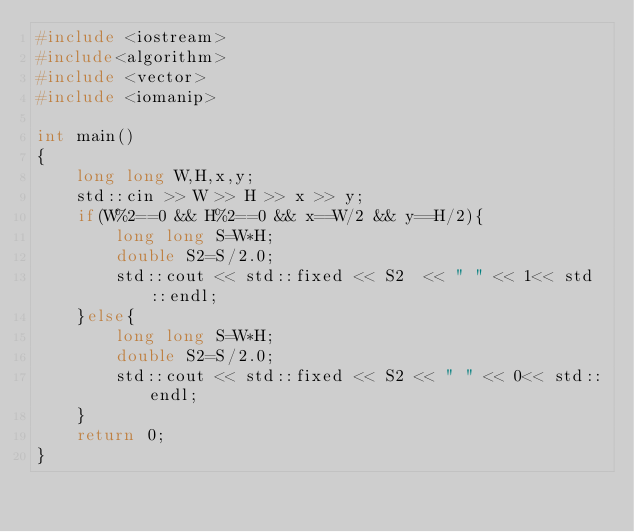<code> <loc_0><loc_0><loc_500><loc_500><_C++_>#include <iostream>
#include<algorithm>
#include <vector>
#include <iomanip>

int main()
{
    long long W,H,x,y;
    std::cin >> W >> H >> x >> y;
    if(W%2==0 && H%2==0 && x==W/2 && y==H/2){
        long long S=W*H;
        double S2=S/2.0;
        std::cout << std::fixed << S2  << " " << 1<< std::endl; 
    }else{
        long long S=W*H;
        double S2=S/2.0;
        std::cout << std::fixed << S2 << " " << 0<< std::endl; 
    }
    return 0;
}</code> 